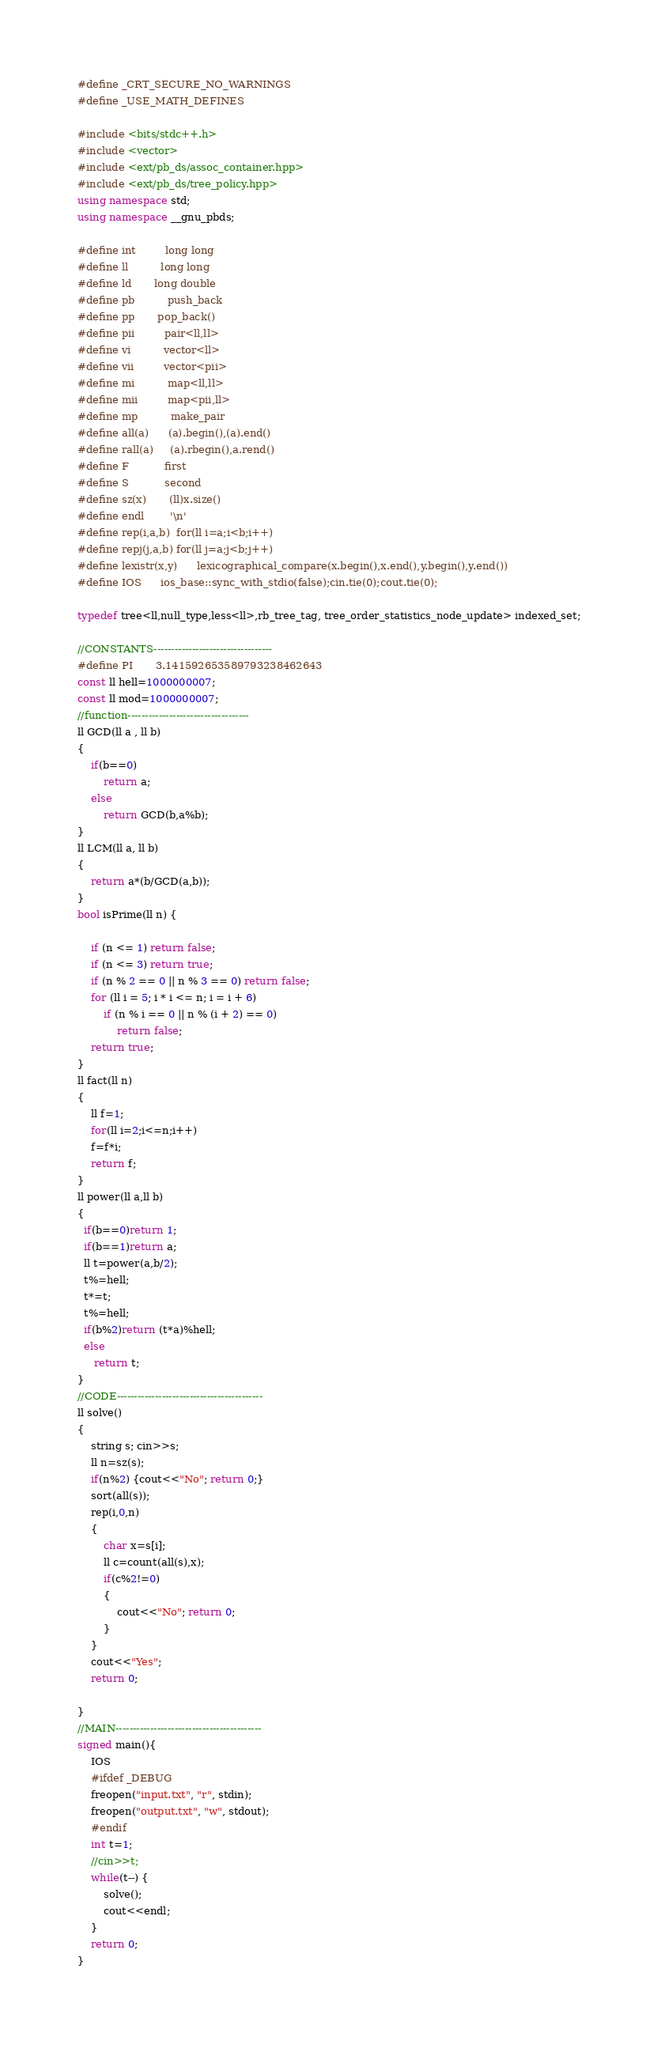<code> <loc_0><loc_0><loc_500><loc_500><_C++_>#define _CRT_SECURE_NO_WARNINGS
#define _USE_MATH_DEFINES

#include <bits/stdc++.h>
#include <vector>
#include <ext/pb_ds/assoc_container.hpp>
#include <ext/pb_ds/tree_policy.hpp>
using namespace std;
using namespace __gnu_pbds;

#define int         long long
#define ll          long long
#define ld	    long double
#define pb          push_back
#define pp	    pop_back()
#define pii         pair<ll,ll>
#define vi          vector<ll>
#define vii         vector<pii>
#define mi          map<ll,ll>
#define mii         map<pii,ll>
#define mp          make_pair
#define all(a)      (a).begin(),(a).end()
#define rall(a)     (a).rbegin(),a.rend()
#define F           first
#define S           second
#define sz(x)       (ll)x.size()
#define endl        '\n'
#define rep(i,a,b)  for(ll i=a;i<b;i++)
#define repj(j,a,b) for(ll j=a;j<b;j++)
#define lexistr(x,y)      lexicographical_compare(x.begin(),x.end(),y.begin(),y.end())
#define IOS	    ios_base::sync_with_stdio(false);cin.tie(0);cout.tie(0);

typedef tree<ll,null_type,less<ll>,rb_tree_tag, tree_order_statistics_node_update> indexed_set;

//CONSTANTS----------------------------------
#define PI 	    3.141592653589793238462643
const ll hell=1000000007;
const ll mod=1000000007;
//function-----------------------------------
ll GCD(ll a , ll b)
{
    if(b==0)
        return a;
    else
        return GCD(b,a%b);
}
ll LCM(ll a, ll b)
{
    return a*(b/GCD(a,b));
}
bool isPrime(ll n) {

    if (n <= 1) return false;
    if (n <= 3) return true;
    if (n % 2 == 0 || n % 3 == 0) return false;
    for (ll i = 5; i * i <= n; i = i + 6)
        if (n % i == 0 || n % (i + 2) == 0)
            return false;
    return true;
}
ll fact(ll n)
{
    ll f=1;
    for(ll i=2;i<=n;i++)
	f=f*i;
    return f;
}
ll power(ll a,ll b)
{
  if(b==0)return 1;
  if(b==1)return a;
  ll t=power(a,b/2);
  t%=hell;
  t*=t;
  t%=hell;
  if(b%2)return (t*a)%hell;
  else
     return t;
}
//CODE------------------------------------------
ll solve()
{
    string s; cin>>s;
    ll n=sz(s);
    if(n%2) {cout<<"No"; return 0;}
    sort(all(s));
    rep(i,0,n)
    {
        char x=s[i];
        ll c=count(all(s),x);
        if(c%2!=0)
        {
            cout<<"No"; return 0;
        }
    }
    cout<<"Yes";
    return 0;

}
//MAIN------------------------------------------
signed main(){
    IOS
    #ifdef _DEBUG
	freopen("input.txt", "r", stdin);
	freopen("output.txt", "w", stdout);
    #endif
    int t=1;
    //cin>>t;
    while(t--) {
        solve();
        cout<<endl;
    }
    return 0;
}
</code> 